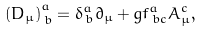Convert formula to latex. <formula><loc_0><loc_0><loc_500><loc_500>\left ( D _ { \mu } \right ) _ { \, b } ^ { a } = \delta _ { \, b } ^ { a } \partial _ { \mu } + g f _ { \, b c } ^ { a } A _ { \mu } ^ { c } ,</formula> 